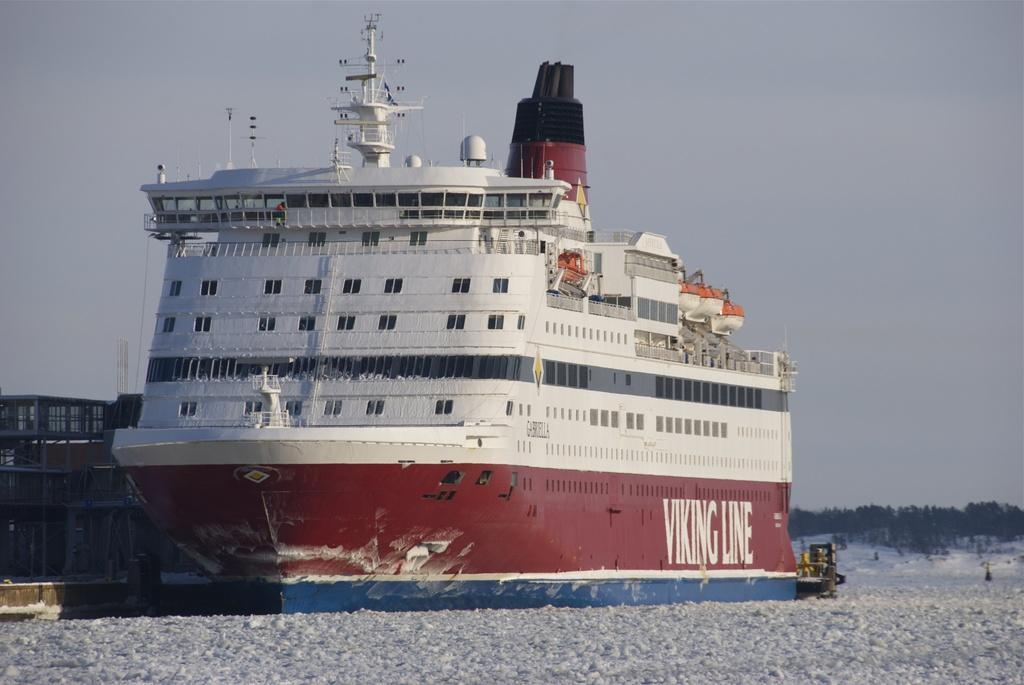How would you summarize this image in a sentence or two? In the given image i can see a ship,water,trees and in the background i can see the sky. 